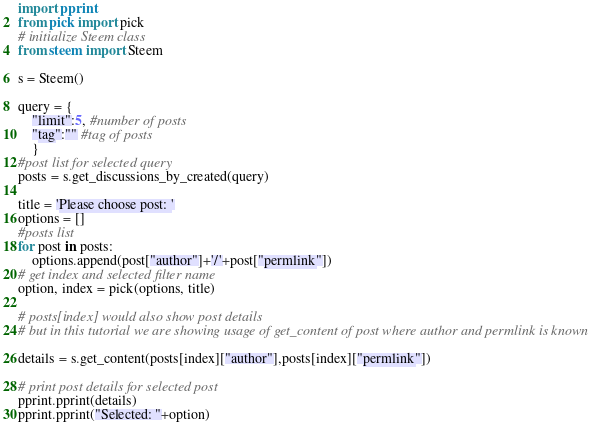Convert code to text. <code><loc_0><loc_0><loc_500><loc_500><_Python_>import pprint
from pick import pick
# initialize Steem class
from steem import Steem

s = Steem()

query = {
	"limit":5, #number of posts
	"tag":"" #tag of posts
	}
#post list for selected query
posts = s.get_discussions_by_created(query)

title = 'Please choose post: '
options = []
#posts list
for post in posts:
	options.append(post["author"]+'/'+post["permlink"])
# get index and selected filter name
option, index = pick(options, title)

# posts[index] would also show post details
# but in this tutorial we are showing usage of get_content of post where author and permlink is known

details = s.get_content(posts[index]["author"],posts[index]["permlink"])

# print post details for selected post
pprint.pprint(details)
pprint.pprint("Selected: "+option)</code> 